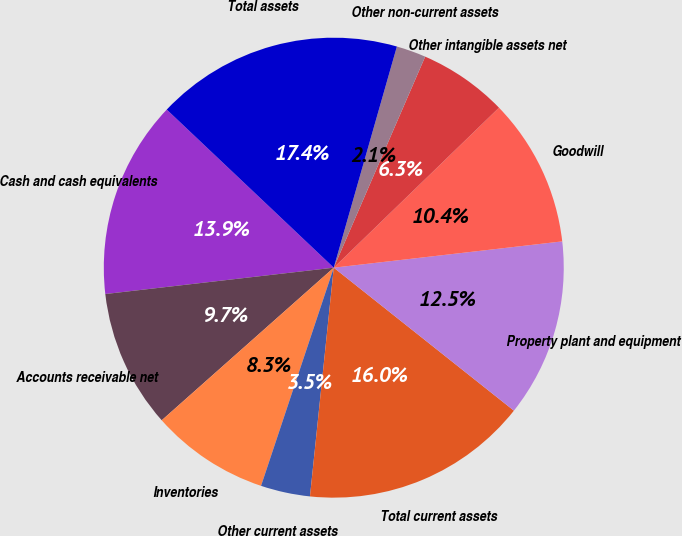<chart> <loc_0><loc_0><loc_500><loc_500><pie_chart><fcel>Cash and cash equivalents<fcel>Accounts receivable net<fcel>Inventories<fcel>Other current assets<fcel>Total current assets<fcel>Property plant and equipment<fcel>Goodwill<fcel>Other intangible assets net<fcel>Other non-current assets<fcel>Total assets<nl><fcel>13.89%<fcel>9.72%<fcel>8.33%<fcel>3.47%<fcel>15.97%<fcel>12.5%<fcel>10.42%<fcel>6.25%<fcel>2.08%<fcel>17.36%<nl></chart> 